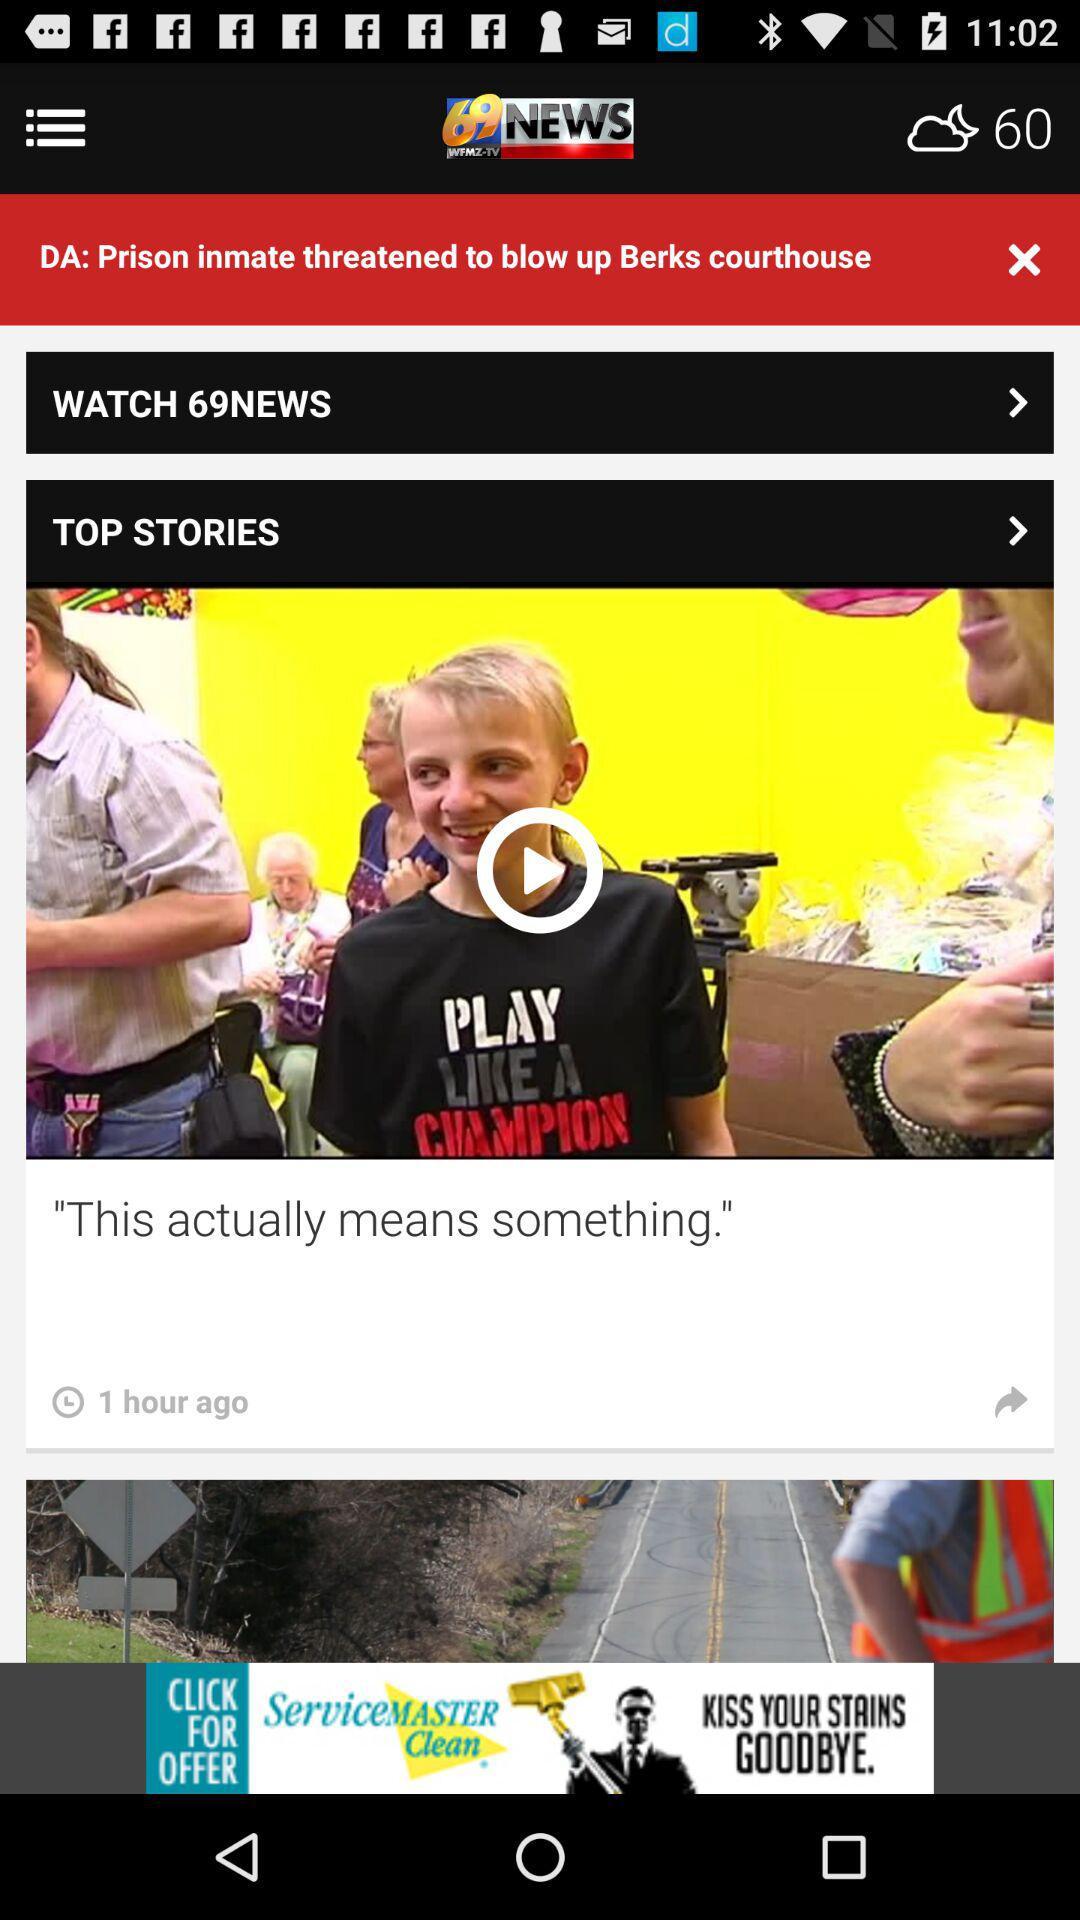How's the Weather?
When the provided information is insufficient, respond with <no answer>. <no answer> 